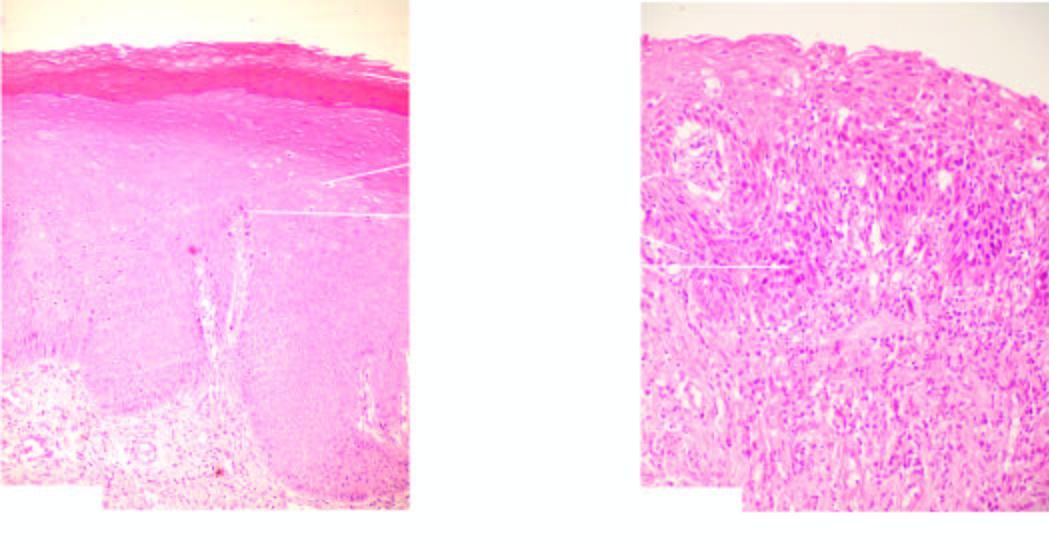what is there?
Answer the question using a single word or phrase. Keratosis and orderly arrangement of increased number of layers of stratified mucosa 